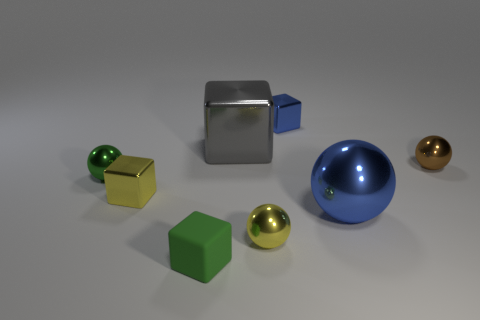Add 1 large cyan matte balls. How many objects exist? 9 Subtract all small metallic balls. How many balls are left? 1 Subtract all green spheres. How many spheres are left? 3 Subtract 2 spheres. How many spheres are left? 2 Subtract 0 yellow cylinders. How many objects are left? 8 Subtract all brown spheres. Subtract all green cylinders. How many spheres are left? 3 Subtract all matte blocks. Subtract all tiny green spheres. How many objects are left? 6 Add 2 big gray shiny things. How many big gray shiny things are left? 3 Add 7 tiny green rubber things. How many tiny green rubber things exist? 8 